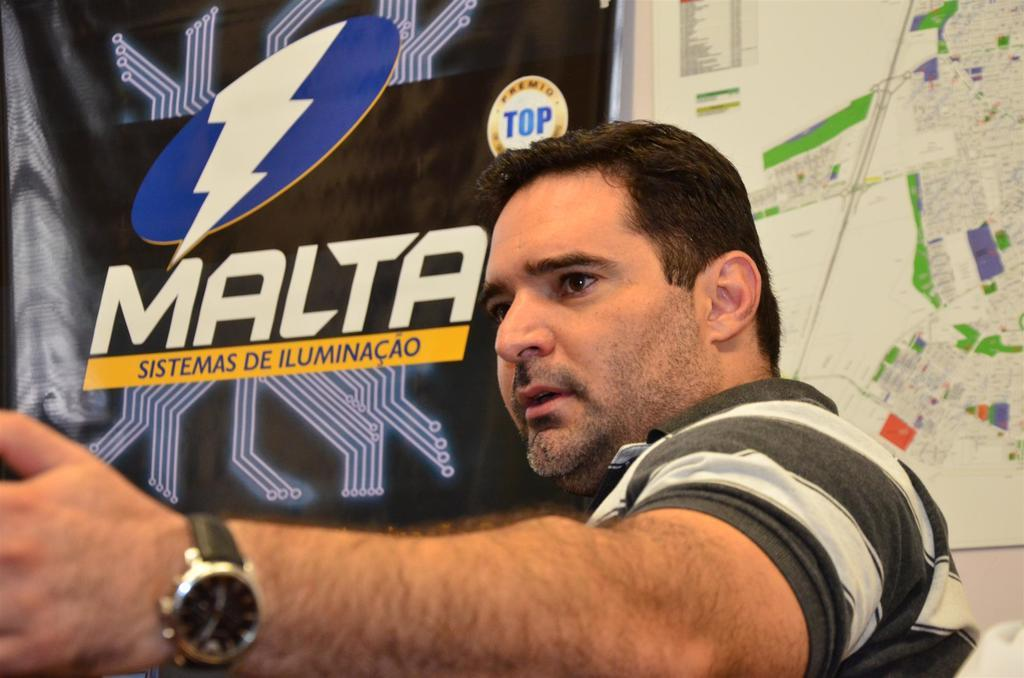<image>
Give a short and clear explanation of the subsequent image. The poster is for the Malta Sistemas Dde Iluminacao 